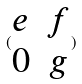<formula> <loc_0><loc_0><loc_500><loc_500>( \begin{matrix} e & f \\ 0 & g \end{matrix} )</formula> 